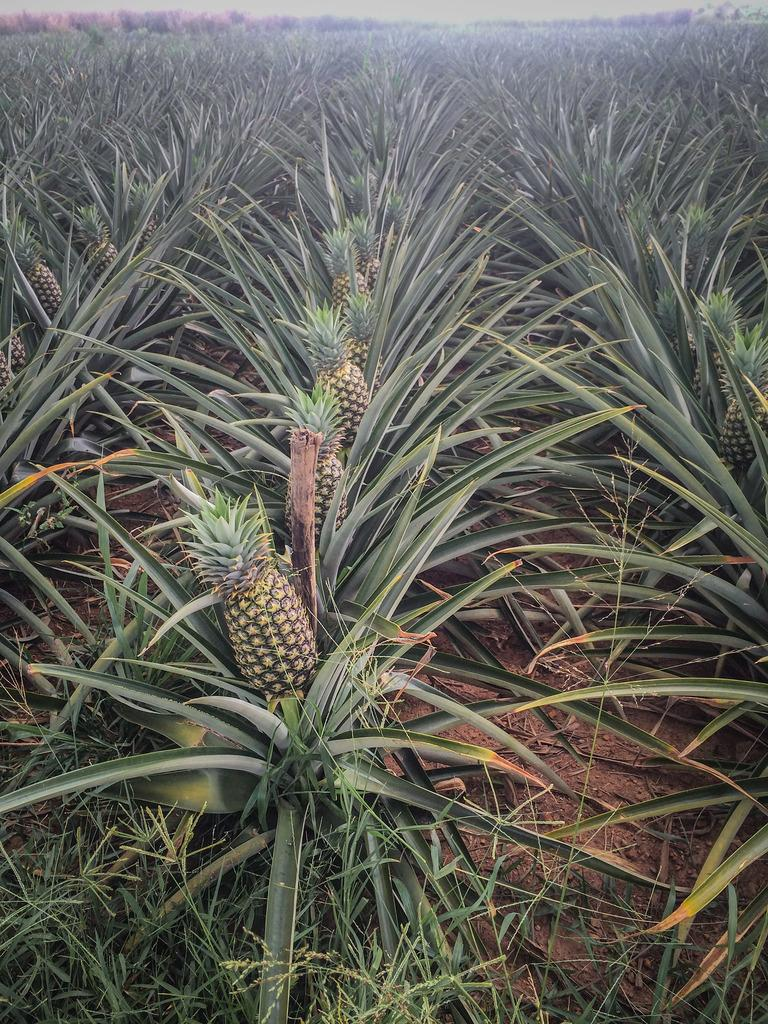What type of plants are visible in the image? There are pineapple plants in the image. What other type of vegetation can be seen in the image? There is grass in the image. What type of plane is visible in the image? There is no plane present in the image; it only features pineapple plants and grass. Is there a crib visible in the image? No, there is no crib present in the image. 